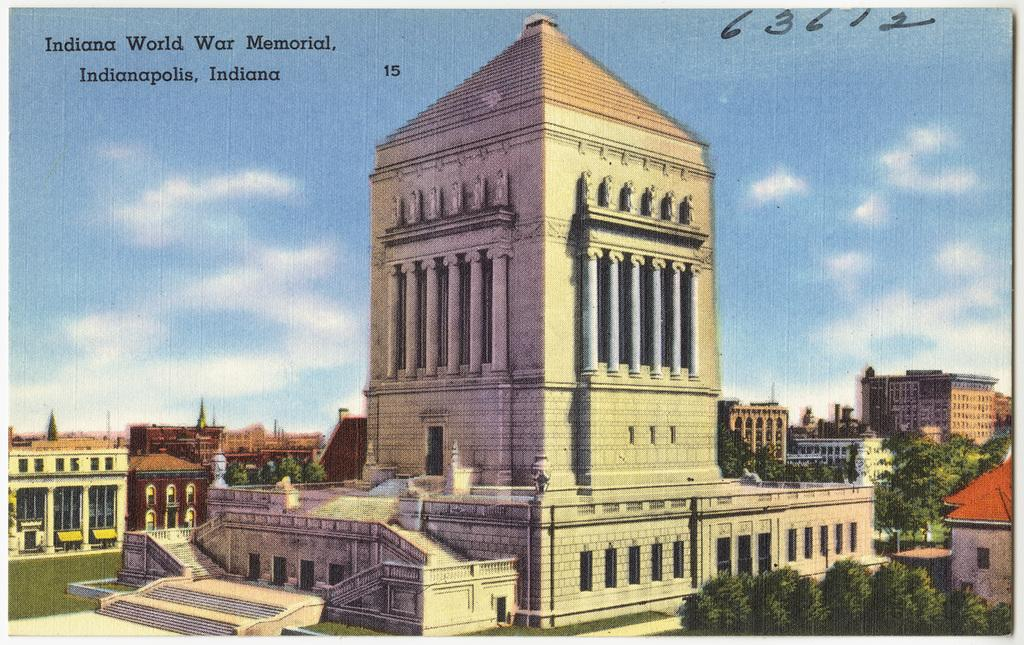Provide a one-sentence caption for the provided image. A drawing of a war memorial for Indianapolis Indiana. 